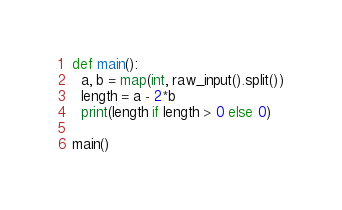Convert code to text. <code><loc_0><loc_0><loc_500><loc_500><_Python_>def main():
  a, b = map(int, raw_input().split())
  length = a - 2*b
  print(length if length > 0 else 0)
  
main()</code> 